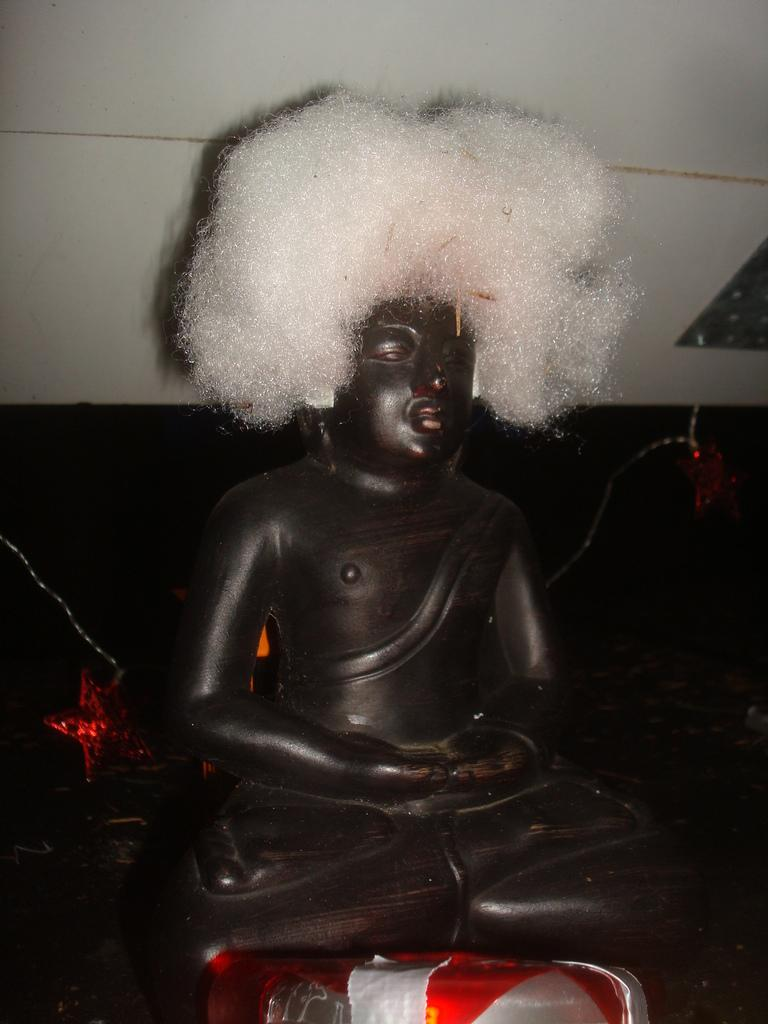What is the main subject in the image? There is a statue in the image. What else can be seen in the image besides the statue? There is an object in the image. What is visible in the background of the image? There is a wall in the background of the image. What type of juice is being served from the apparatus in the image? There is no apparatus or juice present in the image. Can you describe the crow perched on the statue in the image? There is no crow present in the image; only the statue and an object are visible. 